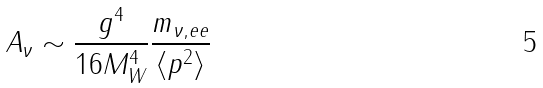<formula> <loc_0><loc_0><loc_500><loc_500>A _ { \nu } \sim \frac { g ^ { 4 } } { 1 6 M _ { W } ^ { 4 } } \frac { m _ { \nu , e e } } { \langle p ^ { 2 } \rangle }</formula> 